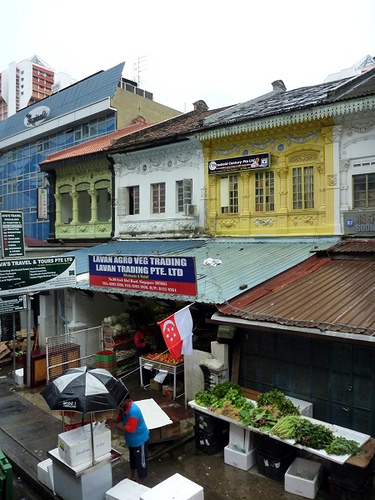<image>
Is there a man to the left of the roof? Yes. From this viewpoint, the man is positioned to the left side relative to the roof. 